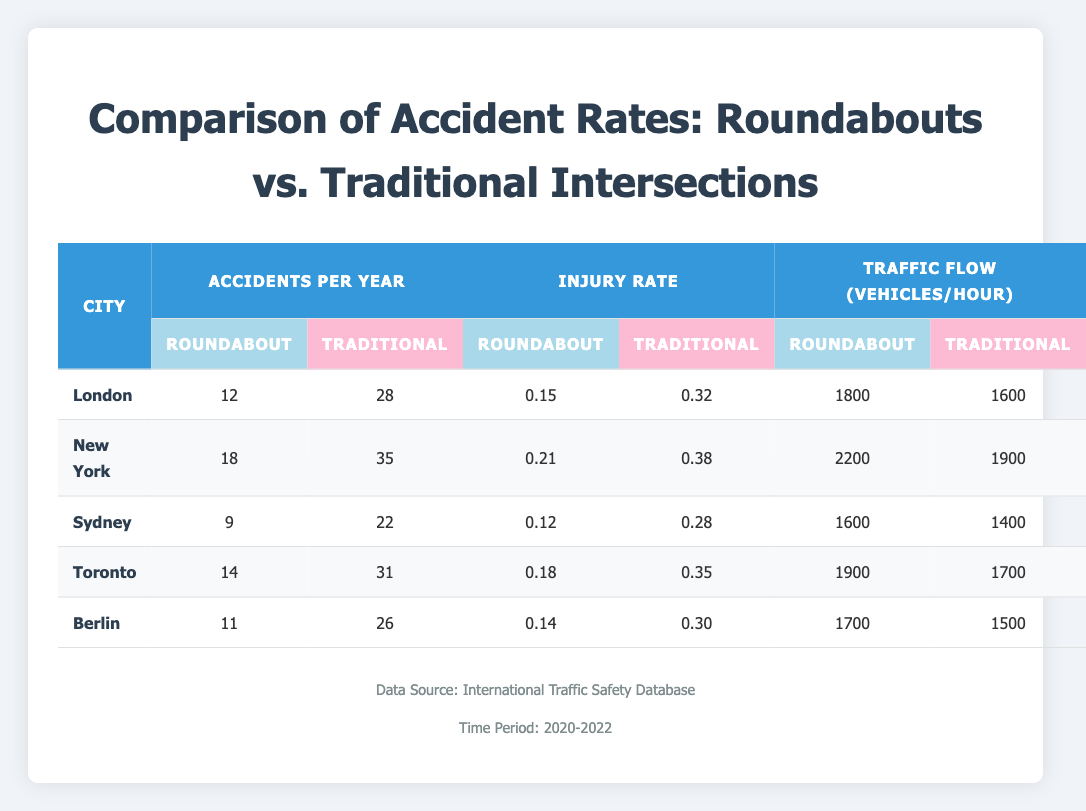What city has the highest number of traditional intersection accidents per year? Looking at the table, New York has the highest number of traditional intersection accidents per year with a total of 35.
Answer: New York Which city has the lowest injury rate for roundabouts? The table shows that Sydney has the lowest injury rate for roundabouts at 0.12.
Answer: Sydney What is the average number of roundabout accidents per year across all cities? The total number of roundabout accidents per year is (12 + 18 + 9 + 14 + 11) = 64. There are 5 cities, so the average is 64/5 = 12.8.
Answer: 12.8 Is the traffic flow for roundabouts in Toronto higher than that in Berlin? According to the table, the traffic flow for roundabouts in Toronto is 1900 vehicles/hour, while in Berlin it is 1700 vehicles/hour. Since 1900 is greater than 1700, the statement is true.
Answer: Yes What is the difference in traditional accident rates between London and Sydney? London has 28 traditional accidents per year and Sydney has 22. The difference is calculated as 28 - 22 = 6.
Answer: 6 Which intersection type has a higher average injury rate and what is that rate? For roundabouts, the injury rates are 0.15 (London), 0.21 (New York), 0.12 (Sydney), 0.18 (Toronto), and 0.14 (Berlin). The average is (0.15 + 0.21 + 0.12 + 0.18 + 0.14) = 0.80; dividing by 5 gives an average of 0.16. For traditional intersections, the injury rates are 0.32 (London), 0.38 (New York), 0.28 (Sydney), 0.35 (Toronto), and 0.30 (Berlin), totaling 1.63 and averaging 0.326. Traditional intersections have the higher average injury rate of 0.326.
Answer: Traditional intersections: 0.326 What is the total traffic flow for roundabouts across all cities? The sum of the traffic flow for roundabouts in each city is 1800 (London) + 2200 (New York) + 1600 (Sydney) + 1900 (Toronto) + 1700 (Berlin) = 10200 vehicles/hour.
Answer: 10200 vehicles/hour Are the roundabout injury rates in New York and Toronto greater than 0.2? New York has a roundabout injury rate of 0.21, and Toronto has 0.18. Since only New York exceeds 0.2, the statement is false.
Answer: No 